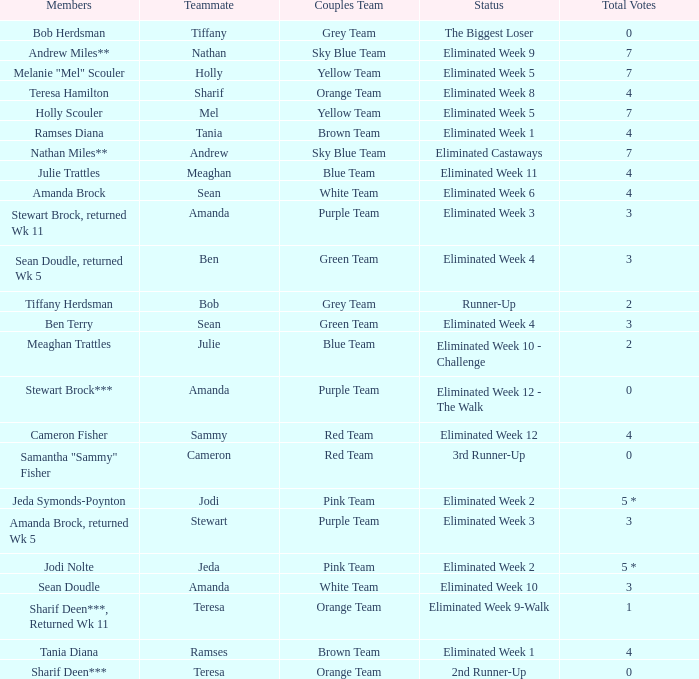Who had 0 total votes in the purple team? Eliminated Week 12 - The Walk. 